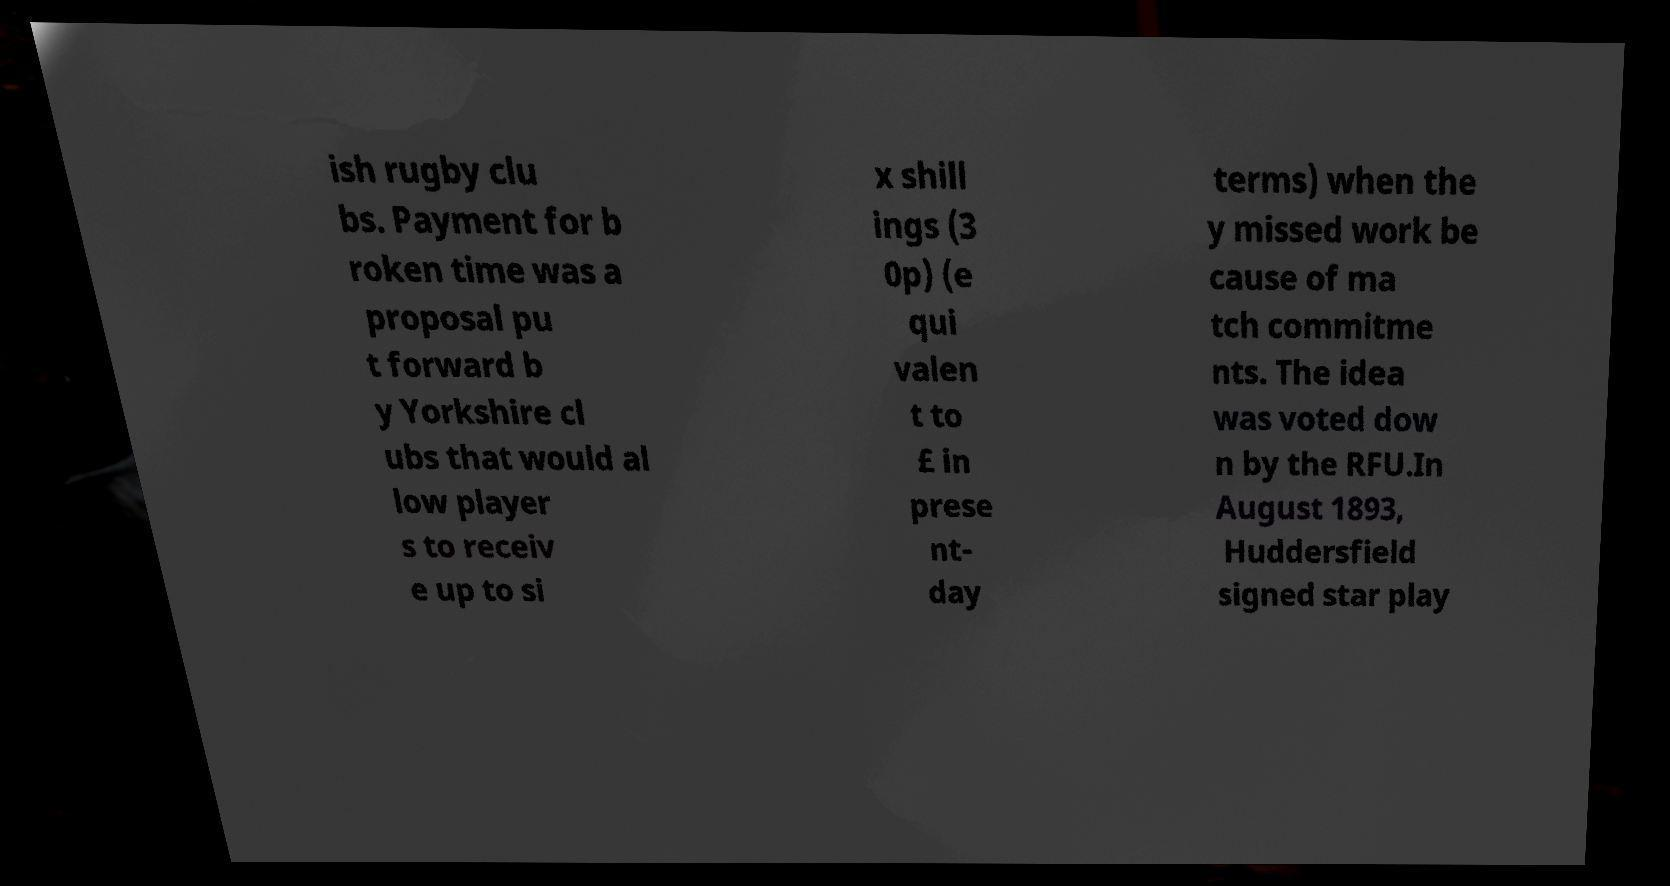Can you accurately transcribe the text from the provided image for me? ish rugby clu bs. Payment for b roken time was a proposal pu t forward b y Yorkshire cl ubs that would al low player s to receiv e up to si x shill ings (3 0p) (e qui valen t to £ in prese nt- day terms) when the y missed work be cause of ma tch commitme nts. The idea was voted dow n by the RFU.In August 1893, Huddersfield signed star play 